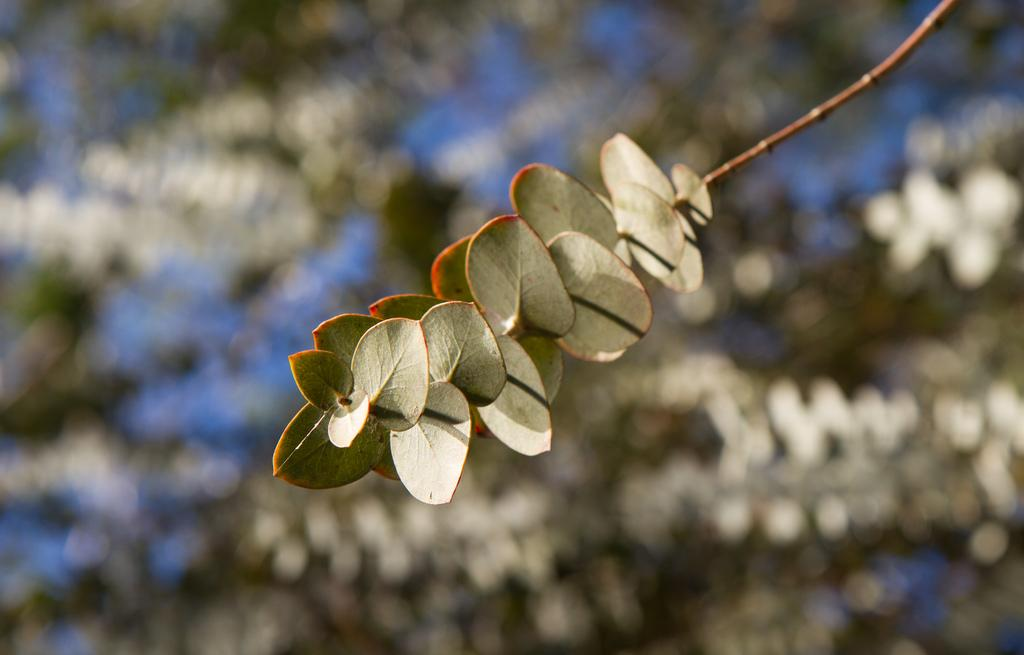What is located in the foreground of the image? There is a stem with leaves in the foreground of the image. What can be observed about the background of the image? The background of the image is blurred. What type of pan is being used to make the jelly in the image? There is no pan or jelly present in the image; it only features a stem with leaves in the foreground and a blurred background. 